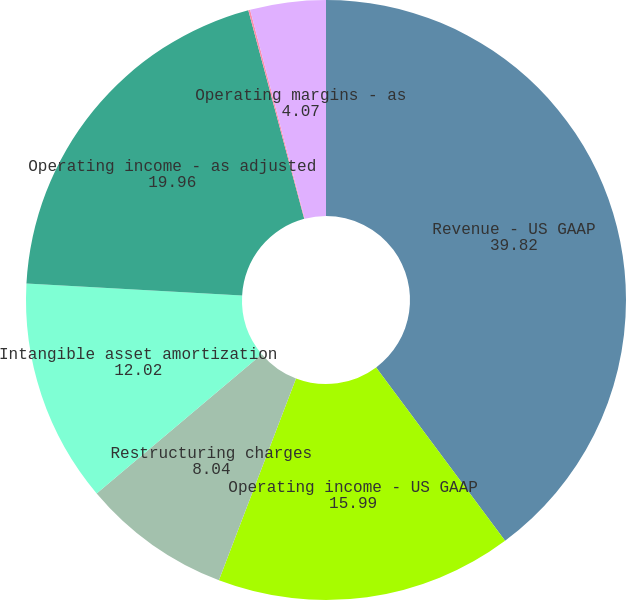<chart> <loc_0><loc_0><loc_500><loc_500><pie_chart><fcel>Revenue - US GAAP<fcel>Operating income - US GAAP<fcel>Restructuring charges<fcel>Intangible asset amortization<fcel>Operating income - as adjusted<fcel>Operating margins - US GAAP<fcel>Operating margins - as<nl><fcel>39.82%<fcel>15.99%<fcel>8.04%<fcel>12.02%<fcel>19.96%<fcel>0.1%<fcel>4.07%<nl></chart> 